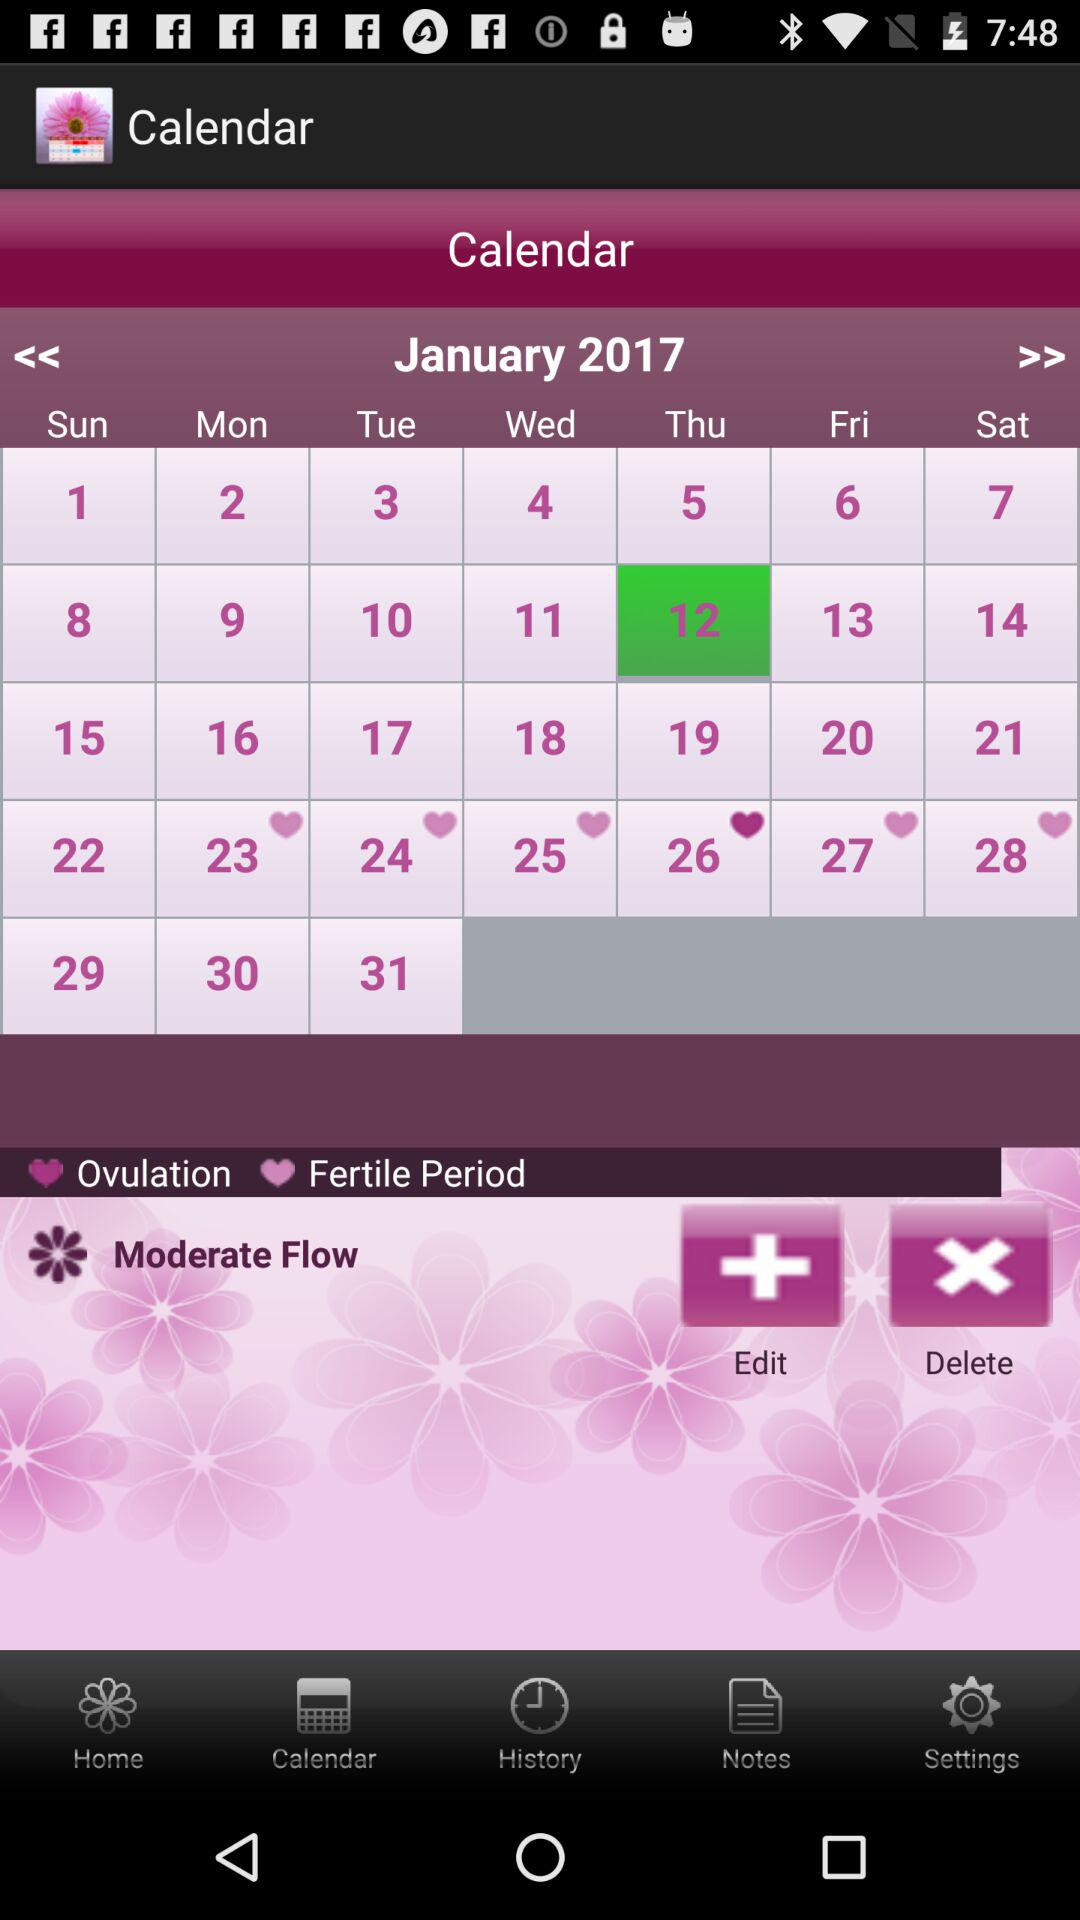Which is the selected month? The selected month is January. 